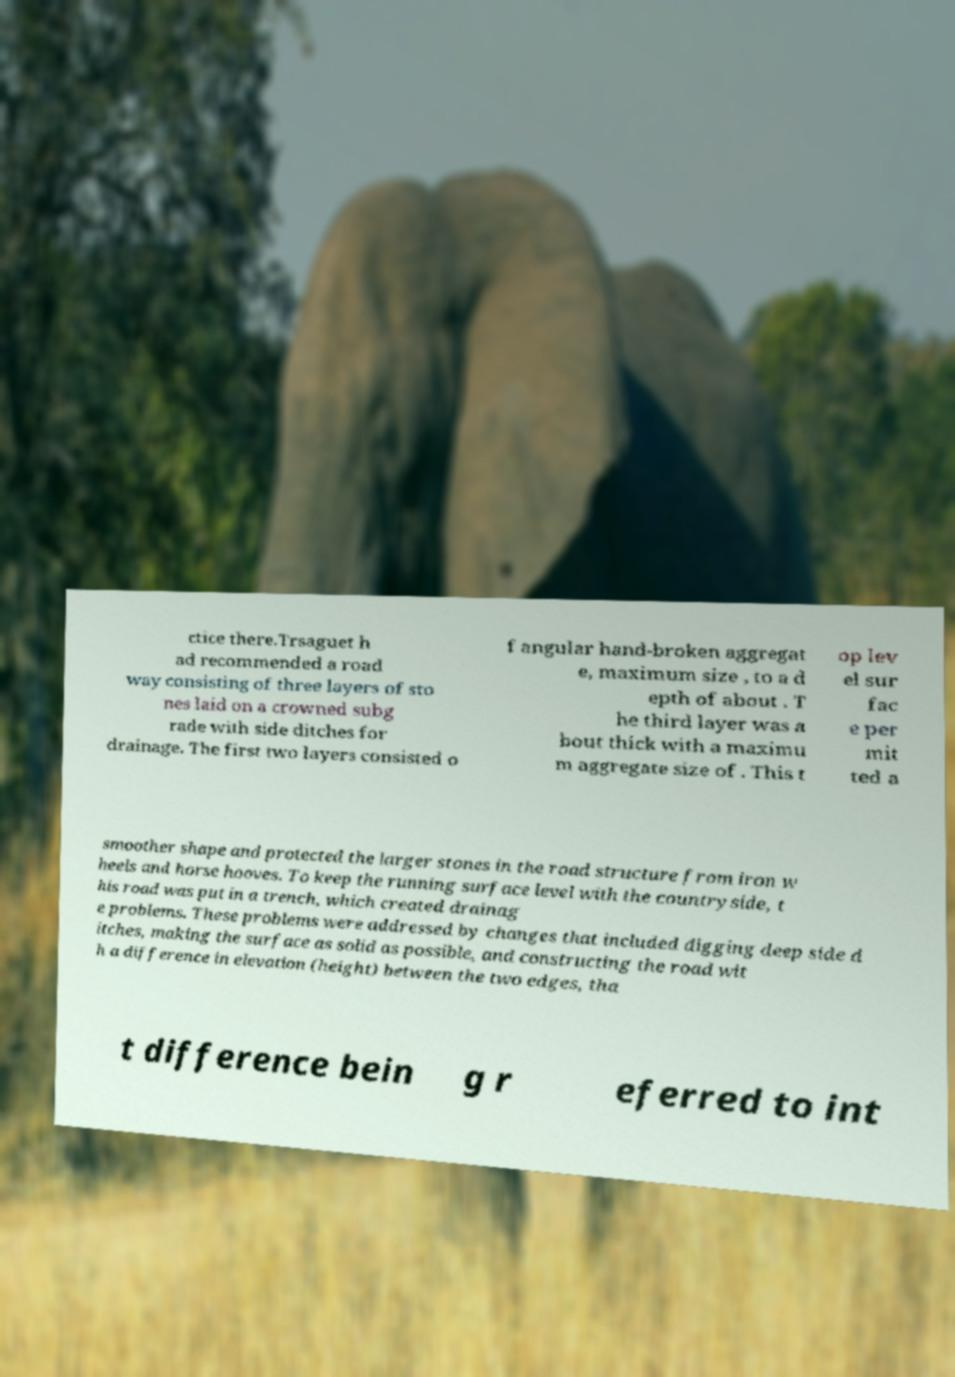Could you extract and type out the text from this image? ctice there.Trsaguet h ad recommended a road way consisting of three layers of sto nes laid on a crowned subg rade with side ditches for drainage. The first two layers consisted o f angular hand-broken aggregat e, maximum size , to a d epth of about . T he third layer was a bout thick with a maximu m aggregate size of . This t op lev el sur fac e per mit ted a smoother shape and protected the larger stones in the road structure from iron w heels and horse hooves. To keep the running surface level with the countryside, t his road was put in a trench, which created drainag e problems. These problems were addressed by changes that included digging deep side d itches, making the surface as solid as possible, and constructing the road wit h a difference in elevation (height) between the two edges, tha t difference bein g r eferred to int 